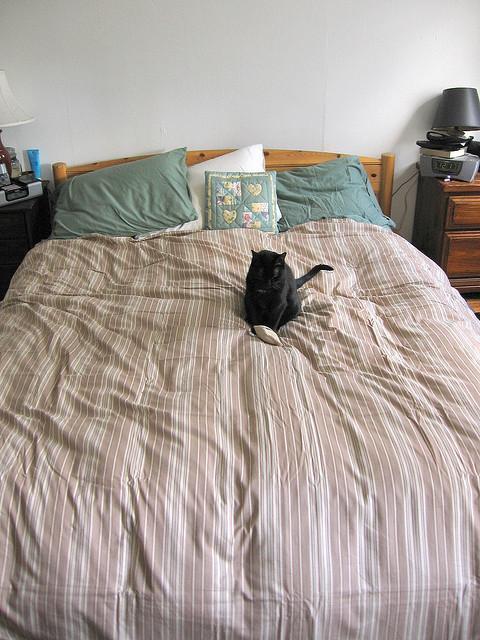How many toothbrushes in the cup?
Give a very brief answer. 0. 